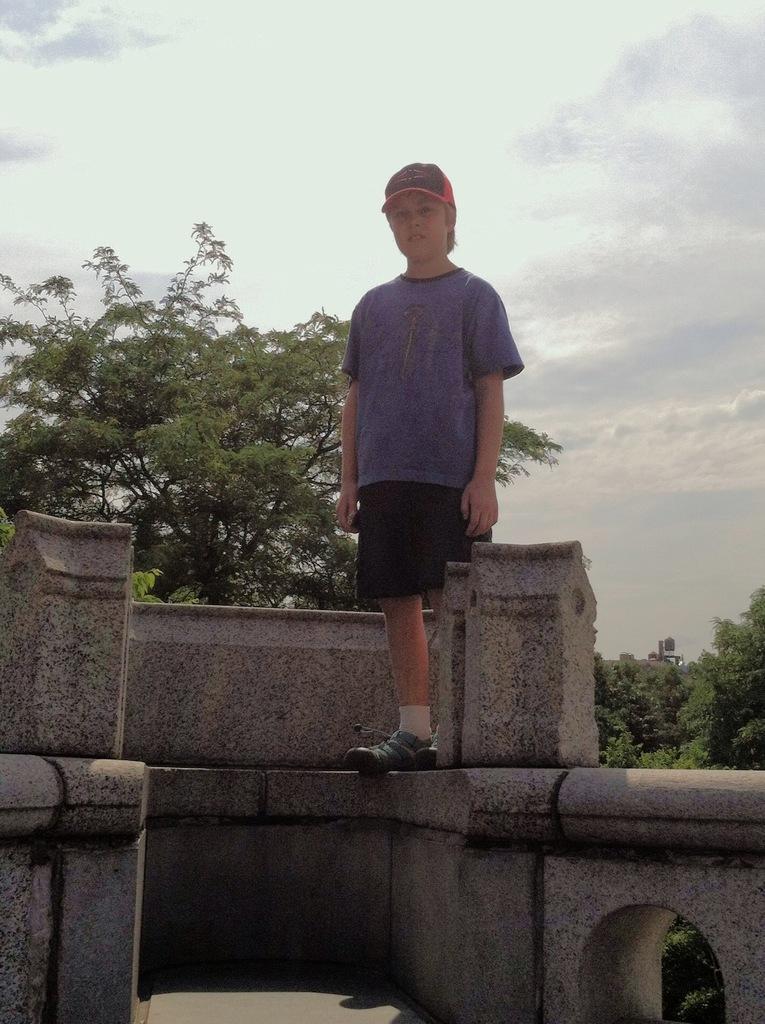In one or two sentences, can you explain what this image depicts? In this image I can see a person standing on a wall and looking at the picture. In the background there are many trees. At the top of the image I can see the sky and clouds. 